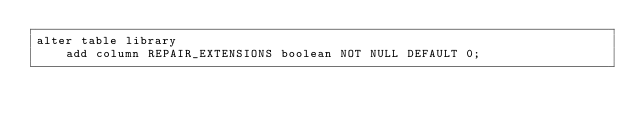Convert code to text. <code><loc_0><loc_0><loc_500><loc_500><_SQL_>alter table library
    add column REPAIR_EXTENSIONS boolean NOT NULL DEFAULT 0;
</code> 